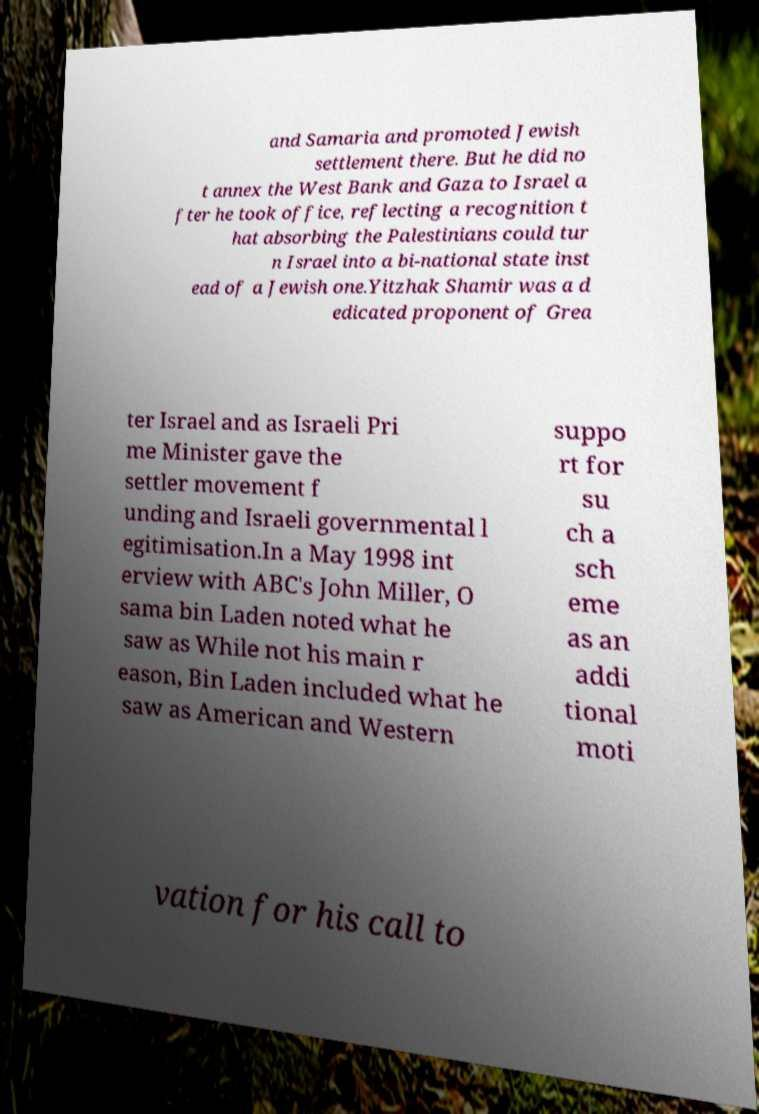Please read and relay the text visible in this image. What does it say? and Samaria and promoted Jewish settlement there. But he did no t annex the West Bank and Gaza to Israel a fter he took office, reflecting a recognition t hat absorbing the Palestinians could tur n Israel into a bi-national state inst ead of a Jewish one.Yitzhak Shamir was a d edicated proponent of Grea ter Israel and as Israeli Pri me Minister gave the settler movement f unding and Israeli governmental l egitimisation.In a May 1998 int erview with ABC's John Miller, O sama bin Laden noted what he saw as While not his main r eason, Bin Laden included what he saw as American and Western suppo rt for su ch a sch eme as an addi tional moti vation for his call to 